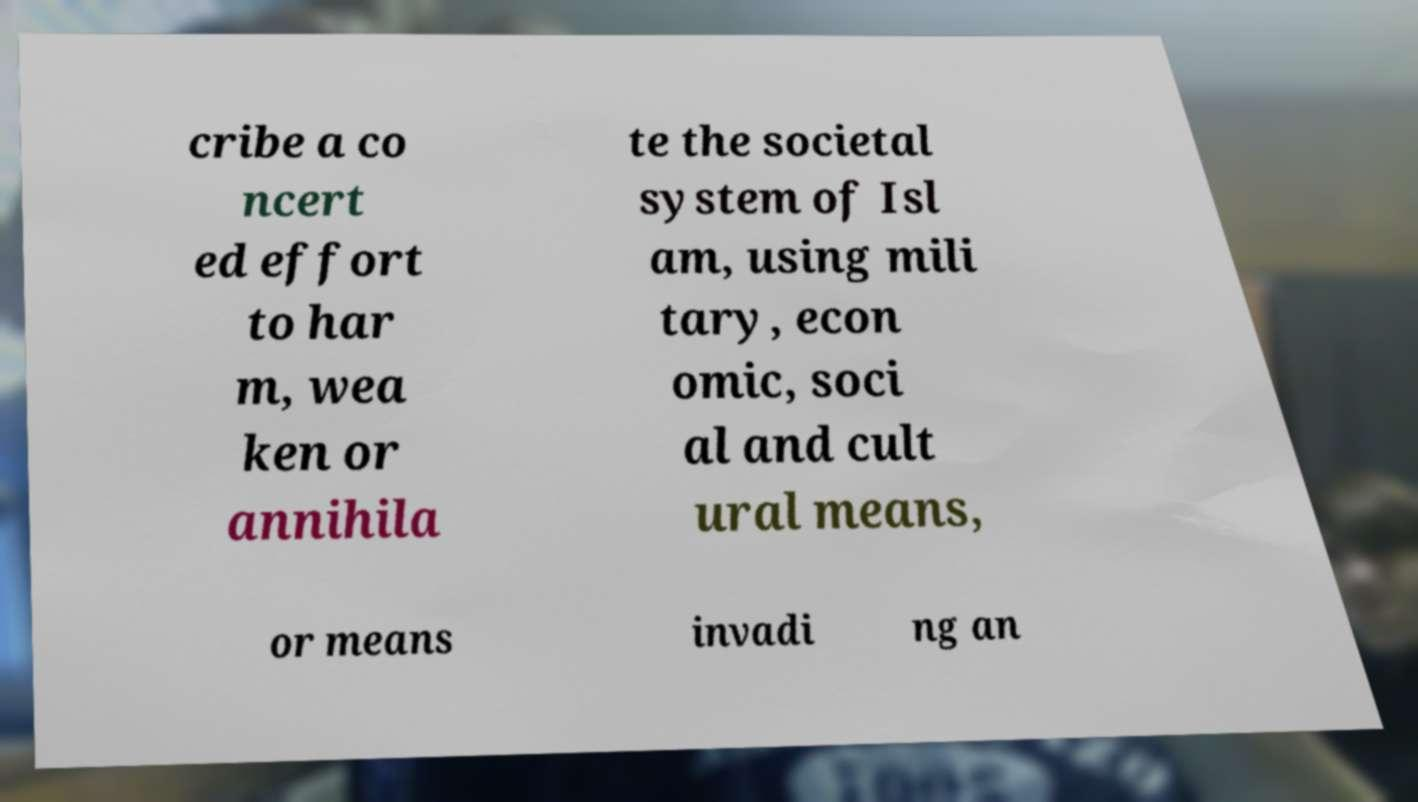Could you extract and type out the text from this image? cribe a co ncert ed effort to har m, wea ken or annihila te the societal system of Isl am, using mili tary, econ omic, soci al and cult ural means, or means invadi ng an 